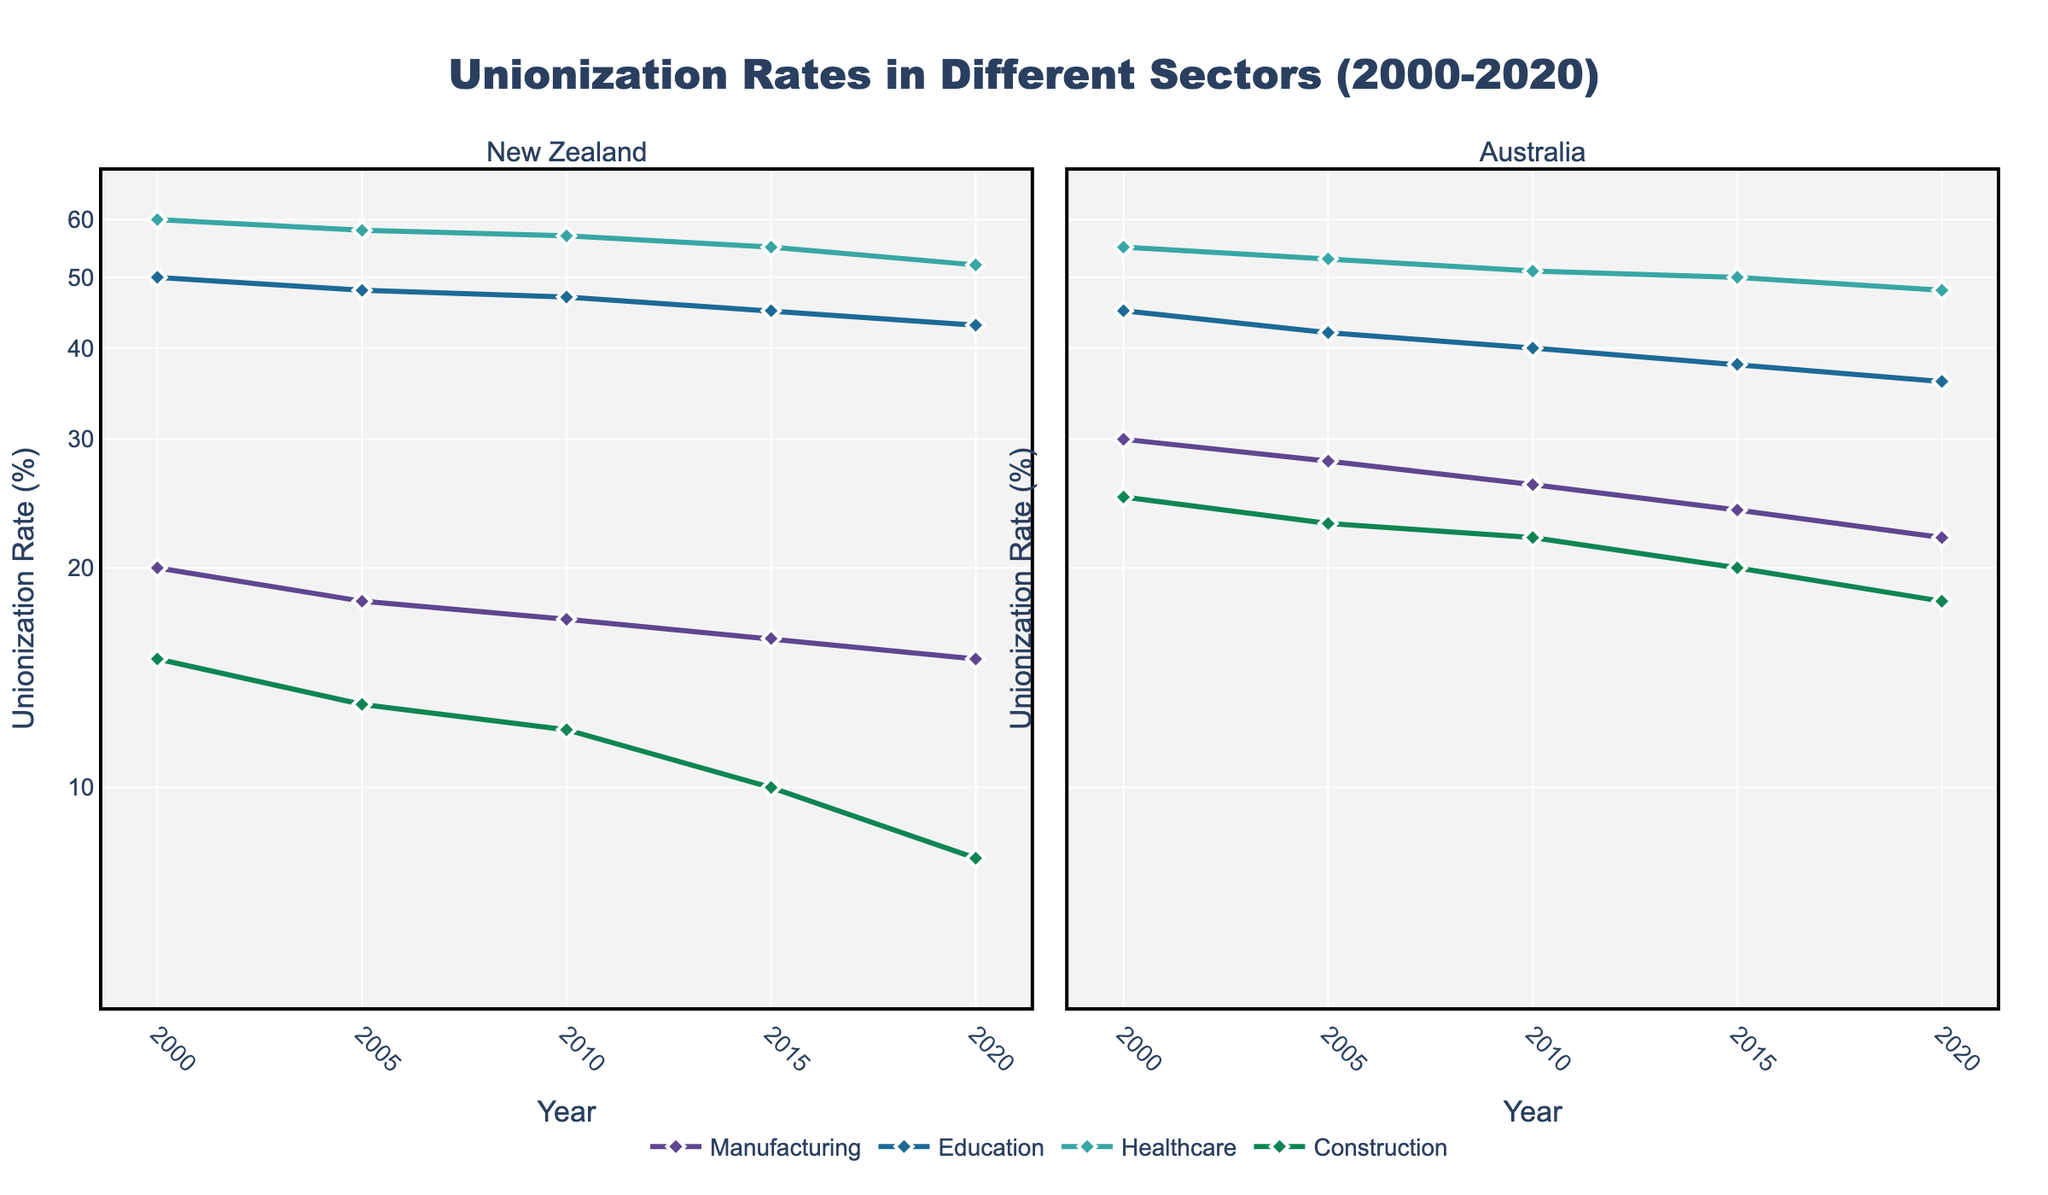How does the unionization rate in New Zealand's healthcare sector compare to Australia's healthcare sector in 2020? To compare the unionization rates in 2020, look at the data points for both countries' healthcare sectors in the year 2020. New Zealand's healthcare has a rate of 52%, while Australia's is 48%.
Answer: New Zealand's rate is higher Between 2000 and 2020, which sector in New Zealand saw the most significant decline in unionization rate? To determine the sector with the most significant decline, examine the trends for each sector in New Zealand from 2000 to 2020. Construction saw a decrease from 15% to 8%. This is a 7% decline, which is the largest among all sectors.
Answer: Construction Which sector in Australia had the highest unionization rate in 2005? Look at the data points for each sector in Australia in the year 2005. Healthcare has the highest rate, showing 53%.
Answer: Healthcare What is the difference in the unionization rate of the manufacturing sector between New Zealand and Australia in 2015? Compare the unionization rates for the manufacturing sector in both countries in 2015. Australia's rate is 24%, and New Zealand's rate is 16%. The difference is 24% - 16% = 8%.
Answer: 8% By looking at the trends, which sector in New Zealand remained relatively stable in its unionization rate from 2000 to 2020? Identify the sector with minimal changes over the years. The education sector in New Zealand remains the most stable, with rates fluctuating slightly between 50% and 43%.
Answer: Education How does the change in unionization rates for the healthcare sector in Australia compare from 2000 to 2020? To find the change, compare the 2000 and 2020 rates for Australia's healthcare sector. The rate decreases from 55% to 48%, a change of 55% - 48% = 7%.
Answer: Decreased by 7% Which country had higher unionization rates in the manufacturing sector consistently over the given period? Check the unionization rates across all years for both countries in the manufacturing sector. Australia consistently had higher rates compared to New Zealand.
Answer: Australia Are there any sectors in New Zealand showing an upward trend in unionization rates from 2000 to 2020? Look at the lines representing different sectors in New Zealand to see if any show an upward trend. None of the sectors show an upward trend.
Answer: No What's the average unionization rate in the education sector in New Zealand over the years 2000, 2005, 2010, 2015, and 2020? Sum the rates over the years and divide by the number of data points: (50% + 48% + 47% + 45% + 43%)/5 = 46.6%.
Answer: 46.6% 